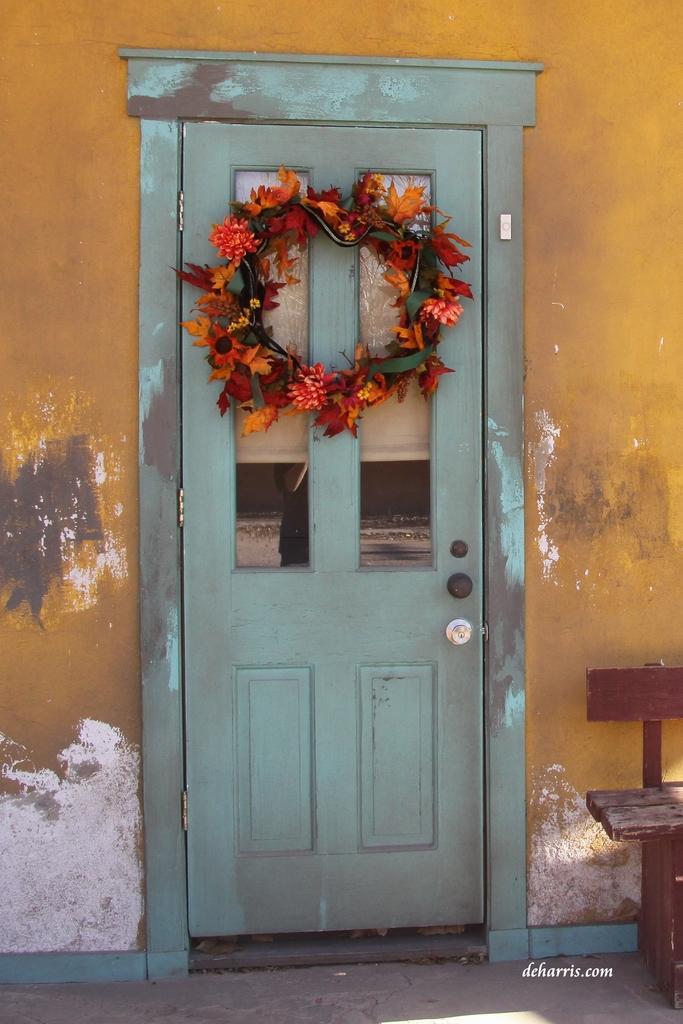Can you describe this image briefly? This image consists of a door. It is in blue color. There is a bench on the right side. 